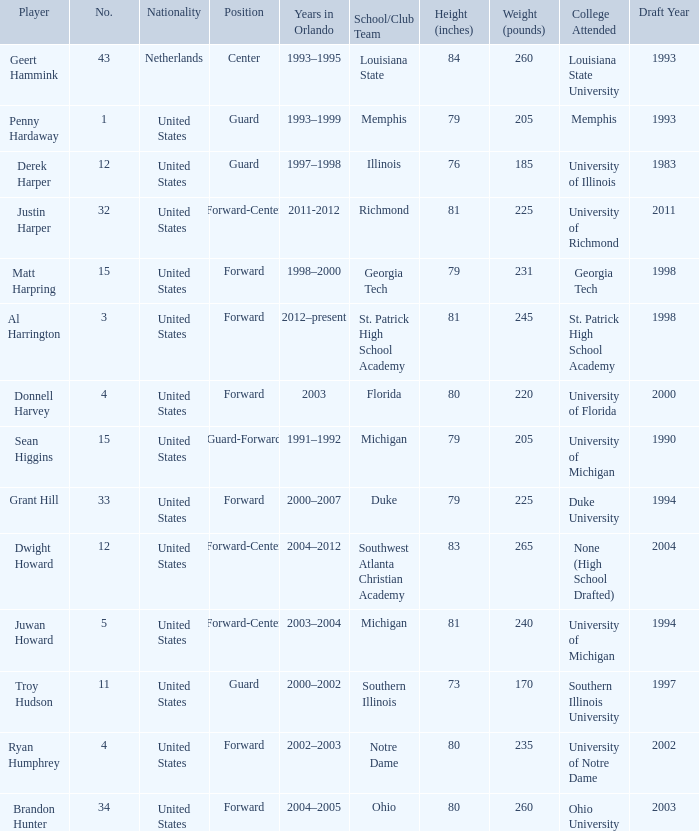What school did Dwight Howard play for Southwest Atlanta Christian Academy. 